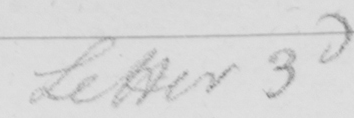Can you tell me what this handwritten text says? Letter 3d 